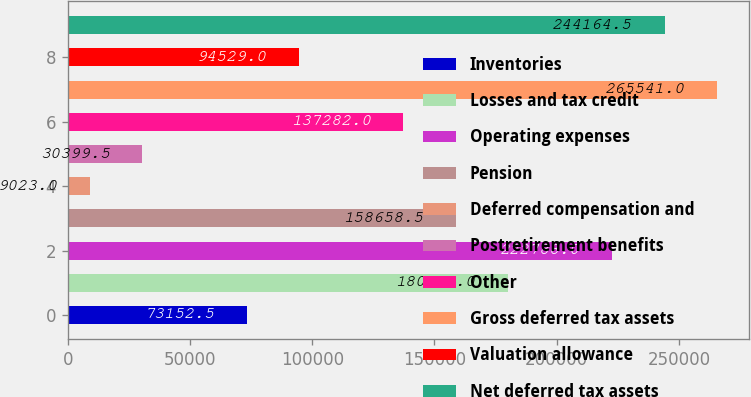<chart> <loc_0><loc_0><loc_500><loc_500><bar_chart><fcel>Inventories<fcel>Losses and tax credit<fcel>Operating expenses<fcel>Pension<fcel>Deferred compensation and<fcel>Postretirement benefits<fcel>Other<fcel>Gross deferred tax assets<fcel>Valuation allowance<fcel>Net deferred tax assets<nl><fcel>73152.5<fcel>180035<fcel>222788<fcel>158658<fcel>9023<fcel>30399.5<fcel>137282<fcel>265541<fcel>94529<fcel>244164<nl></chart> 